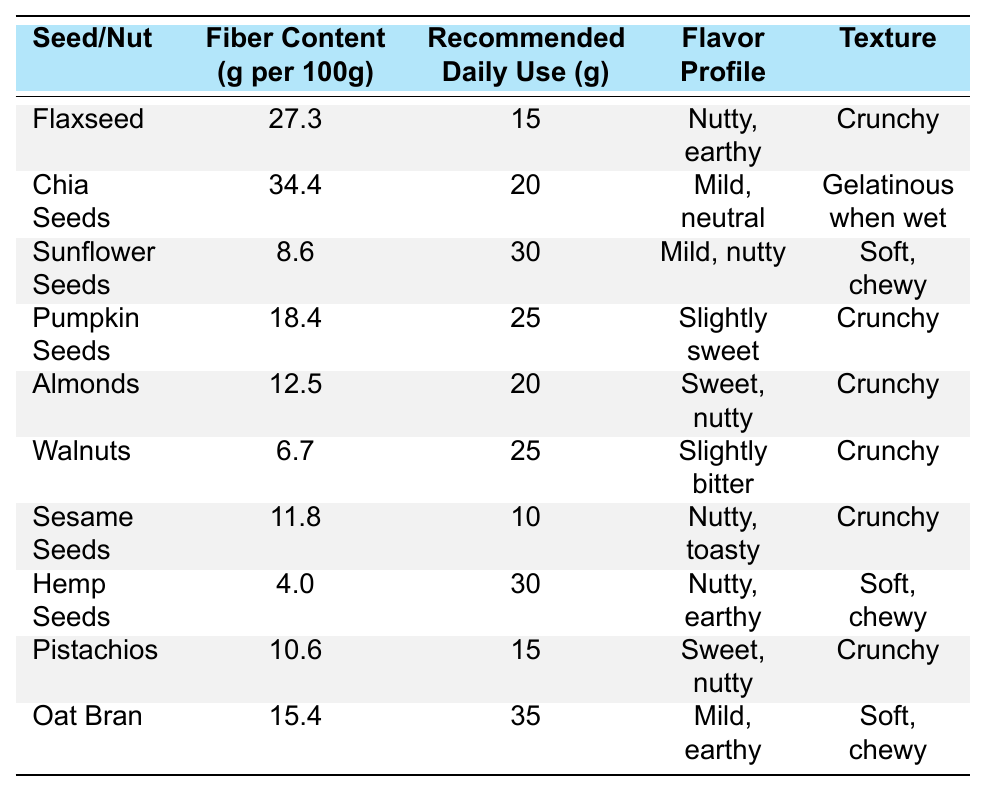What is the fiber content of chia seeds? The table shows that chia seeds have a fiber content of 34.4 grams per 100 grams.
Answer: 34.4 g Which seed has the highest fiber content? By examining the fiber content values in the table, chia seeds have the highest fiber content at 34.4 grams per 100 grams.
Answer: Chia Seeds What is the recommended daily use of almonds? According to the table, the recommended daily use of almonds is 20 grams.
Answer: 20 g Are sunflower seeds softer in texture compared to flaxseeds? The table categorizes sunflower seeds as "Soft, chewy" and flaxseeds as "Crunchy", indicating that sunflower seeds are indeed softer.
Answer: Yes Calculate the average fiber content of pumpkin seeds, almonds, and walnuts. The fiber content values are: pumpkin seeds (18.4 g), almonds (12.5 g), and walnuts (6.7 g). The total is 18.4 + 12.5 + 6.7 = 37.6 g. There are three seeds, so the average is 37.6/3 = 12.53 g.
Answer: 12.53 g Is the flavor profile of hemp seeds nutty, earthy? The table states that hemp seeds have a flavor profile of "Nutty, earthy", so the statement is true.
Answer: Yes Which has more fiber content, flaxseeds or pumpkin seeds? Flaxseeds have 27.3 grams of fiber while pumpkin seeds have 18.4 grams. Since 27.3 is greater than 18.4, flaxseeds have more fiber.
Answer: Flaxseeds How many grams of sunflower seeds should be used daily? The table indicates that the recommended daily use of sunflower seeds is 30 grams.
Answer: 30 g What combinations of seeds can provide more than 50 grams of fiber if consumed at their recommended daily use? To see if the combination exceeds 50 grams: Chia seeds (34.4 g), flaxseeds (27.3 g), and pumpkin seeds (18.4 g). The total for chia and flax is 34.4 + 27.3 = 61.7 g, which exceeds 50 grams. Therefore, combining chia and flax provides more than 50 grams.
Answer: Chia and Flaxseeds Is the fiber content of sesame seeds greater than that of hemp seeds? Sesame seeds contain 11.8 grams, while hemp seeds contain only 4.0 grams, so sesame seeds have greater fiber content.
Answer: Yes 